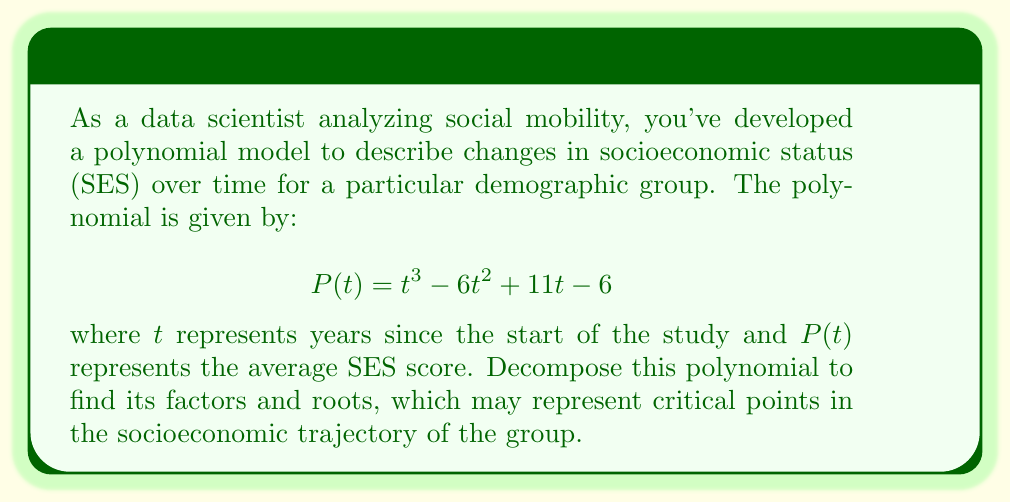Can you answer this question? To decompose this polynomial, we'll follow these steps:

1) First, let's check if there are any rational roots using the rational root theorem. The possible rational roots are the factors of the constant term: ±1, ±2, ±3, ±6.

2) Testing these values, we find that $P(1) = 0$. So $(t-1)$ is a factor.

3) We can use polynomial long division to divide $P(t)$ by $(t-1)$:

   $$\frac{t^3 - 6t^2 + 11t - 6}{t-1} = t^2 - 5t + 6$$

4) Now we have: $P(t) = (t-1)(t^2 - 5t + 6)$

5) The quadratic factor $t^2 - 5t + 6$ can be factored further:
   
   $$t^2 - 5t + 6 = (t-2)(t-3)$$

6) Therefore, the complete factorization is:

   $$P(t) = (t-1)(t-2)(t-3)$$

7) The roots of the polynomial are the values that make each factor zero: $t = 1$, $t = 2$, and $t = 3$.

These roots represent the years at which the SES score equals zero in this model, which could indicate significant transition points in the socioeconomic trajectory of the group being studied.
Answer: $$P(t) = (t-1)(t-2)(t-3)$$
Roots: $t = 1$, $t = 2$, $t = 3$ 